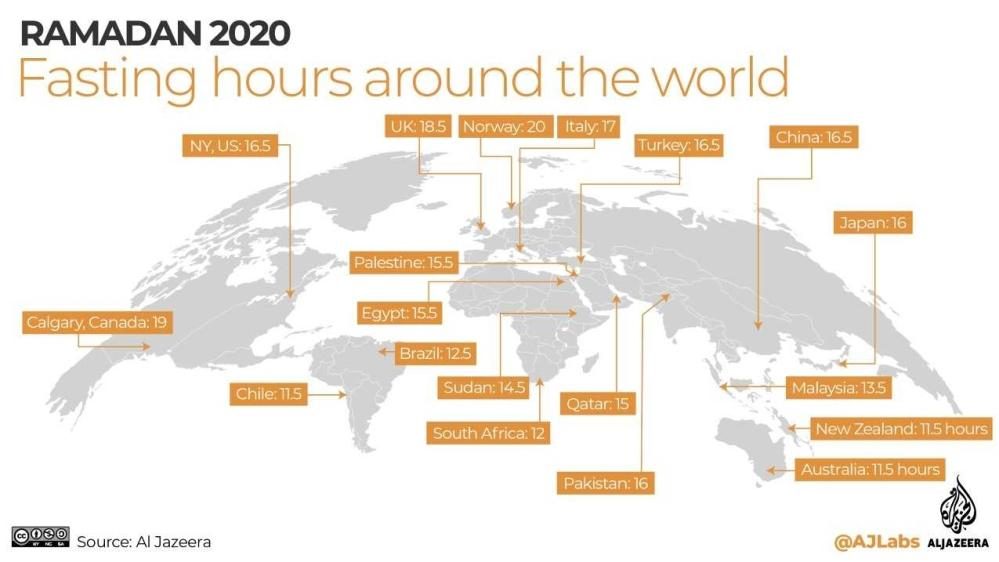Mention a couple of crucial points in this snapshot. The fasting hours in Qatar for Ramadan 2020 will be 15. I am unable to complete your request as it is unclear what you are asking. Can you please provide more context or clarify your question? Norway has the longest fasting hours for Ramadan 2020, according to recent data. 